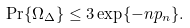<formula> <loc_0><loc_0><loc_500><loc_500>\Pr \{ \Omega _ { \Delta } \} \leq 3 \exp \{ - n p _ { n } \} .</formula> 